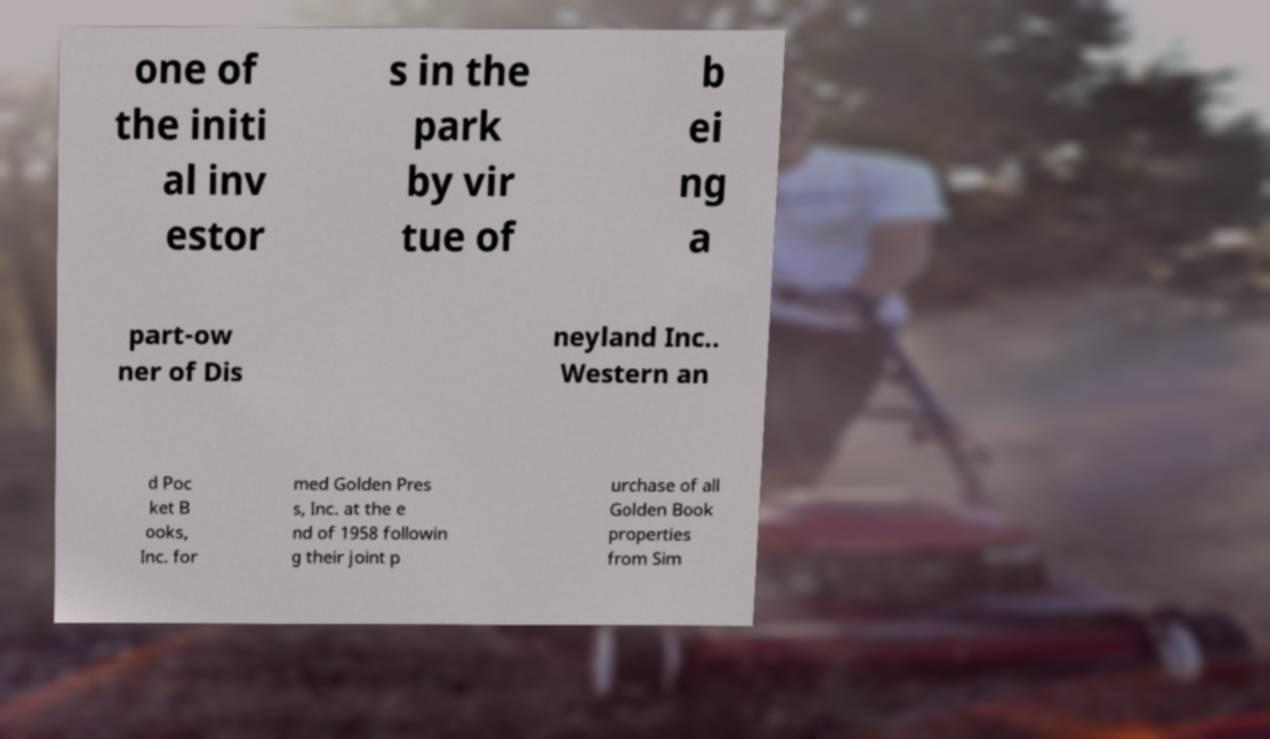Please identify and transcribe the text found in this image. one of the initi al inv estor s in the park by vir tue of b ei ng a part-ow ner of Dis neyland Inc.. Western an d Poc ket B ooks, Inc. for med Golden Pres s, Inc. at the e nd of 1958 followin g their joint p urchase of all Golden Book properties from Sim 